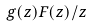<formula> <loc_0><loc_0><loc_500><loc_500>g ( z ) F ( z ) / z</formula> 